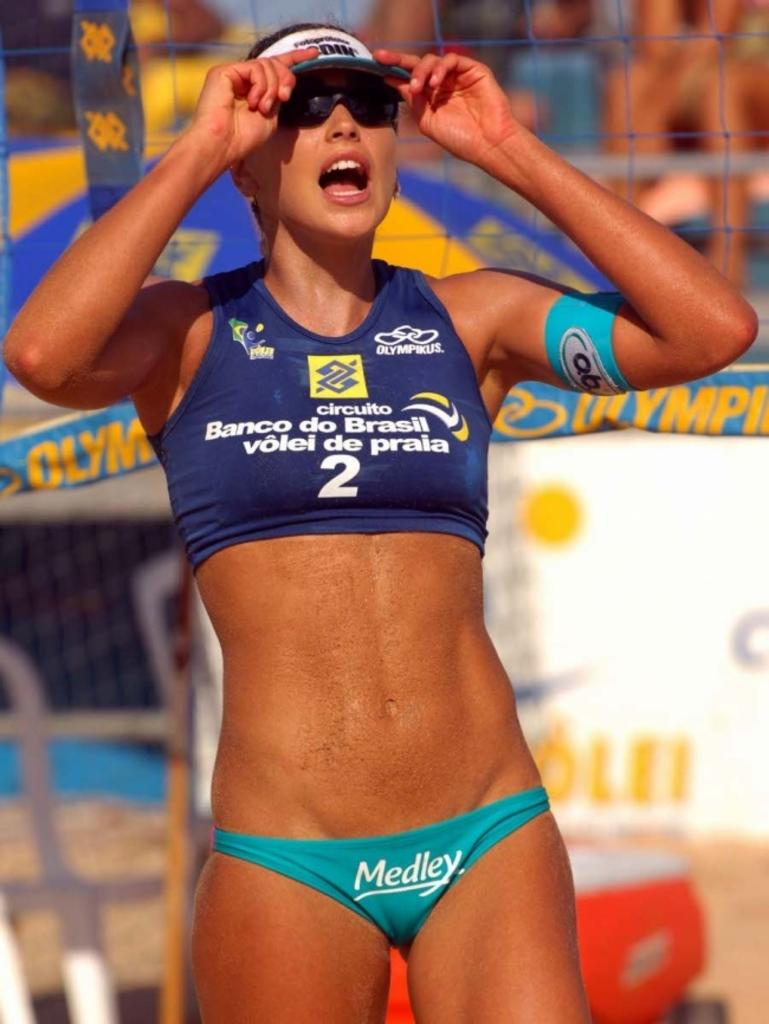Provide a one-sentence caption for the provided image. A lady wearing a swim suit with the word Medley on the bottom. 